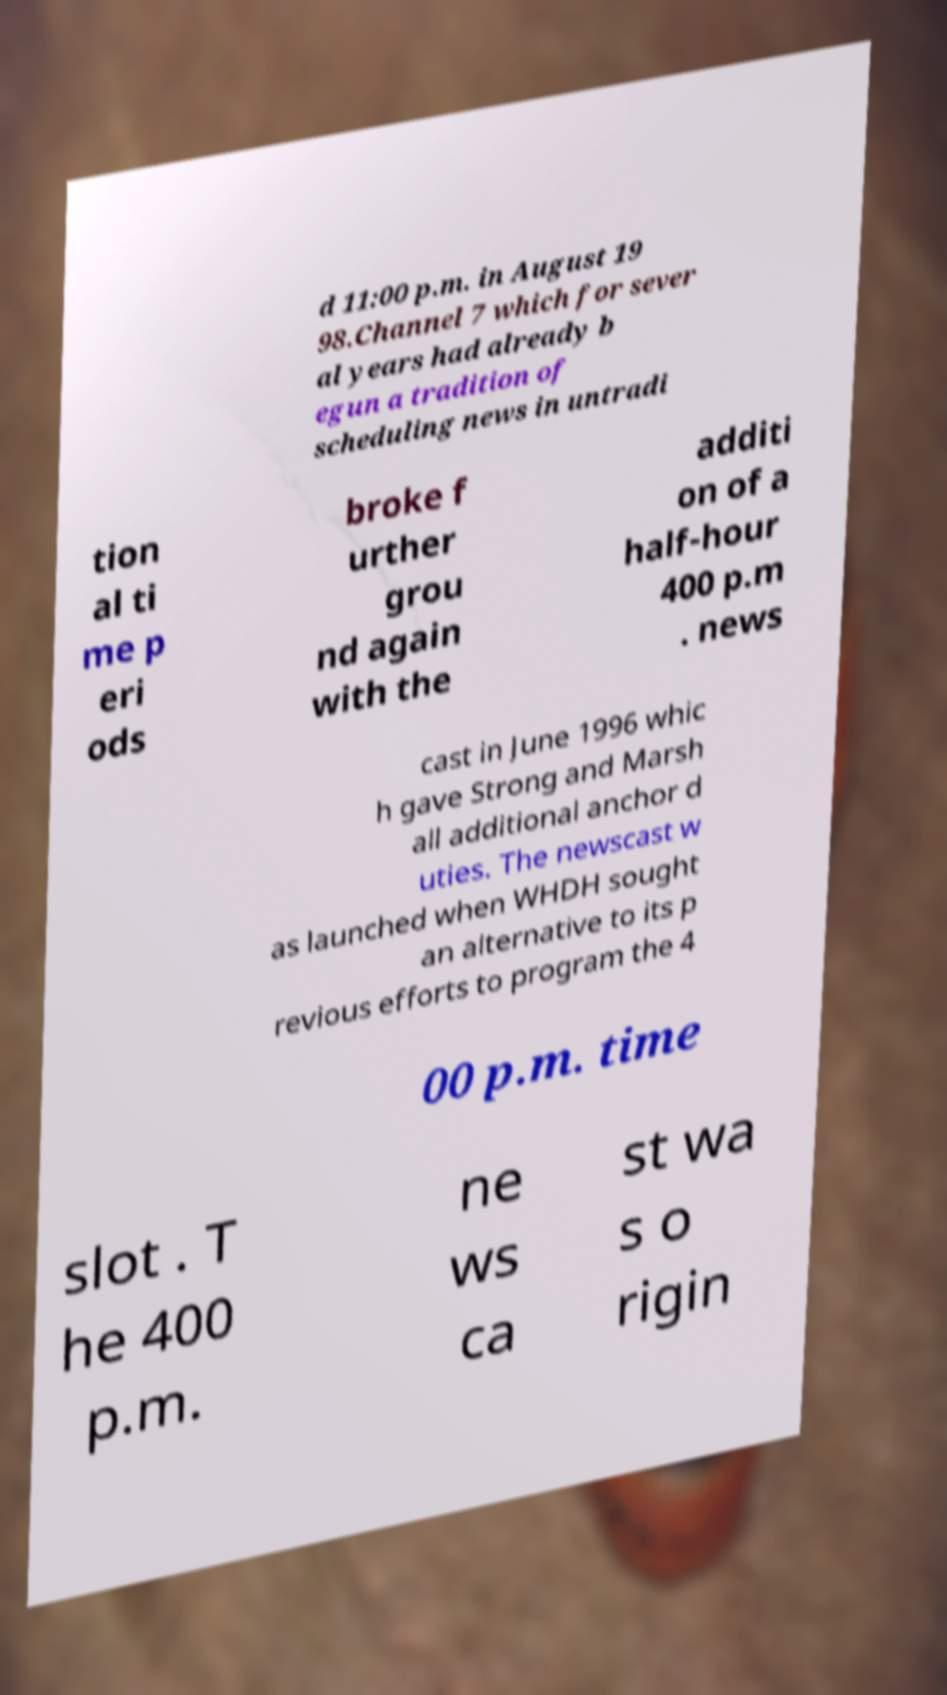There's text embedded in this image that I need extracted. Can you transcribe it verbatim? d 11:00 p.m. in August 19 98.Channel 7 which for sever al years had already b egun a tradition of scheduling news in untradi tion al ti me p eri ods broke f urther grou nd again with the additi on of a half-hour 400 p.m . news cast in June 1996 whic h gave Strong and Marsh all additional anchor d uties. The newscast w as launched when WHDH sought an alternative to its p revious efforts to program the 4 00 p.m. time slot . T he 400 p.m. ne ws ca st wa s o rigin 